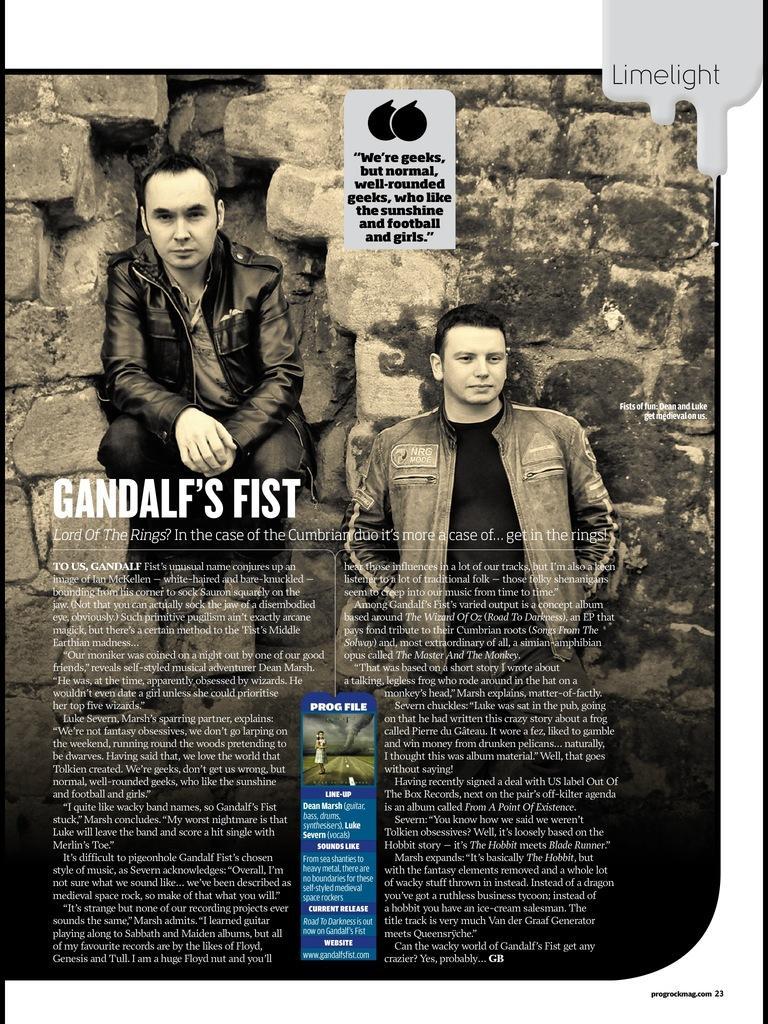Describe this image in one or two sentences. In this image there is a poster, there are two men, there is text, at the background of the image there is a wall. 